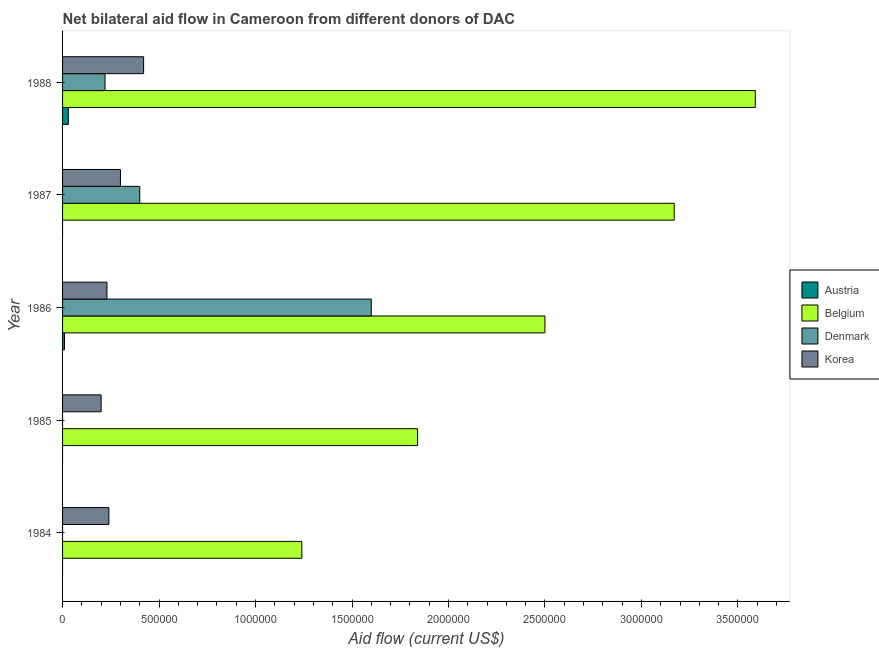How many bars are there on the 3rd tick from the top?
Ensure brevity in your answer.  4. In how many cases, is the number of bars for a given year not equal to the number of legend labels?
Keep it short and to the point. 3. What is the amount of aid given by denmark in 1985?
Your answer should be very brief. 0. Across all years, what is the maximum amount of aid given by austria?
Keep it short and to the point. 3.00e+04. Across all years, what is the minimum amount of aid given by korea?
Provide a succinct answer. 2.00e+05. In which year was the amount of aid given by austria maximum?
Keep it short and to the point. 1988. What is the total amount of aid given by denmark in the graph?
Provide a short and direct response. 2.22e+06. What is the difference between the amount of aid given by korea in 1984 and that in 1988?
Offer a very short reply. -1.80e+05. What is the difference between the amount of aid given by korea in 1984 and the amount of aid given by denmark in 1987?
Keep it short and to the point. -1.60e+05. What is the average amount of aid given by austria per year?
Ensure brevity in your answer.  8000. In the year 1986, what is the difference between the amount of aid given by denmark and amount of aid given by belgium?
Keep it short and to the point. -9.00e+05. In how many years, is the amount of aid given by denmark greater than 500000 US$?
Your answer should be very brief. 1. What is the ratio of the amount of aid given by belgium in 1984 to that in 1987?
Your answer should be compact. 0.39. Is the amount of aid given by korea in 1984 less than that in 1988?
Offer a terse response. Yes. What is the difference between the highest and the second highest amount of aid given by denmark?
Your answer should be very brief. 1.20e+06. What is the difference between the highest and the lowest amount of aid given by korea?
Your answer should be compact. 2.20e+05. How many bars are there?
Your answer should be very brief. 15. Are the values on the major ticks of X-axis written in scientific E-notation?
Provide a short and direct response. No. How many legend labels are there?
Make the answer very short. 4. What is the title of the graph?
Make the answer very short. Net bilateral aid flow in Cameroon from different donors of DAC. What is the Aid flow (current US$) of Austria in 1984?
Keep it short and to the point. 0. What is the Aid flow (current US$) in Belgium in 1984?
Make the answer very short. 1.24e+06. What is the Aid flow (current US$) of Austria in 1985?
Provide a short and direct response. 0. What is the Aid flow (current US$) in Belgium in 1985?
Your answer should be very brief. 1.84e+06. What is the Aid flow (current US$) in Denmark in 1985?
Your response must be concise. 0. What is the Aid flow (current US$) of Korea in 1985?
Your answer should be very brief. 2.00e+05. What is the Aid flow (current US$) of Austria in 1986?
Provide a succinct answer. 10000. What is the Aid flow (current US$) of Belgium in 1986?
Keep it short and to the point. 2.50e+06. What is the Aid flow (current US$) in Denmark in 1986?
Your answer should be very brief. 1.60e+06. What is the Aid flow (current US$) of Korea in 1986?
Your answer should be compact. 2.30e+05. What is the Aid flow (current US$) in Belgium in 1987?
Offer a very short reply. 3.17e+06. What is the Aid flow (current US$) in Denmark in 1987?
Your answer should be very brief. 4.00e+05. What is the Aid flow (current US$) in Korea in 1987?
Your answer should be compact. 3.00e+05. What is the Aid flow (current US$) in Austria in 1988?
Make the answer very short. 3.00e+04. What is the Aid flow (current US$) in Belgium in 1988?
Your answer should be compact. 3.59e+06. What is the Aid flow (current US$) of Denmark in 1988?
Make the answer very short. 2.20e+05. What is the Aid flow (current US$) of Korea in 1988?
Offer a very short reply. 4.20e+05. Across all years, what is the maximum Aid flow (current US$) in Austria?
Your answer should be very brief. 3.00e+04. Across all years, what is the maximum Aid flow (current US$) of Belgium?
Ensure brevity in your answer.  3.59e+06. Across all years, what is the maximum Aid flow (current US$) in Denmark?
Your answer should be very brief. 1.60e+06. Across all years, what is the minimum Aid flow (current US$) of Austria?
Your answer should be compact. 0. Across all years, what is the minimum Aid flow (current US$) in Belgium?
Keep it short and to the point. 1.24e+06. Across all years, what is the minimum Aid flow (current US$) of Denmark?
Make the answer very short. 0. Across all years, what is the minimum Aid flow (current US$) in Korea?
Offer a very short reply. 2.00e+05. What is the total Aid flow (current US$) of Belgium in the graph?
Give a very brief answer. 1.23e+07. What is the total Aid flow (current US$) in Denmark in the graph?
Your answer should be compact. 2.22e+06. What is the total Aid flow (current US$) of Korea in the graph?
Give a very brief answer. 1.39e+06. What is the difference between the Aid flow (current US$) of Belgium in 1984 and that in 1985?
Your answer should be compact. -6.00e+05. What is the difference between the Aid flow (current US$) of Belgium in 1984 and that in 1986?
Your response must be concise. -1.26e+06. What is the difference between the Aid flow (current US$) in Belgium in 1984 and that in 1987?
Provide a short and direct response. -1.93e+06. What is the difference between the Aid flow (current US$) of Korea in 1984 and that in 1987?
Provide a short and direct response. -6.00e+04. What is the difference between the Aid flow (current US$) of Belgium in 1984 and that in 1988?
Offer a very short reply. -2.35e+06. What is the difference between the Aid flow (current US$) in Korea in 1984 and that in 1988?
Offer a terse response. -1.80e+05. What is the difference between the Aid flow (current US$) in Belgium in 1985 and that in 1986?
Offer a very short reply. -6.60e+05. What is the difference between the Aid flow (current US$) in Korea in 1985 and that in 1986?
Give a very brief answer. -3.00e+04. What is the difference between the Aid flow (current US$) of Belgium in 1985 and that in 1987?
Your answer should be compact. -1.33e+06. What is the difference between the Aid flow (current US$) of Belgium in 1985 and that in 1988?
Make the answer very short. -1.75e+06. What is the difference between the Aid flow (current US$) of Belgium in 1986 and that in 1987?
Your answer should be very brief. -6.70e+05. What is the difference between the Aid flow (current US$) in Denmark in 1986 and that in 1987?
Ensure brevity in your answer.  1.20e+06. What is the difference between the Aid flow (current US$) of Belgium in 1986 and that in 1988?
Give a very brief answer. -1.09e+06. What is the difference between the Aid flow (current US$) in Denmark in 1986 and that in 1988?
Keep it short and to the point. 1.38e+06. What is the difference between the Aid flow (current US$) of Korea in 1986 and that in 1988?
Keep it short and to the point. -1.90e+05. What is the difference between the Aid flow (current US$) in Belgium in 1987 and that in 1988?
Your answer should be very brief. -4.20e+05. What is the difference between the Aid flow (current US$) in Denmark in 1987 and that in 1988?
Ensure brevity in your answer.  1.80e+05. What is the difference between the Aid flow (current US$) of Belgium in 1984 and the Aid flow (current US$) of Korea in 1985?
Your answer should be very brief. 1.04e+06. What is the difference between the Aid flow (current US$) of Belgium in 1984 and the Aid flow (current US$) of Denmark in 1986?
Provide a short and direct response. -3.60e+05. What is the difference between the Aid flow (current US$) in Belgium in 1984 and the Aid flow (current US$) in Korea in 1986?
Provide a short and direct response. 1.01e+06. What is the difference between the Aid flow (current US$) of Belgium in 1984 and the Aid flow (current US$) of Denmark in 1987?
Keep it short and to the point. 8.40e+05. What is the difference between the Aid flow (current US$) of Belgium in 1984 and the Aid flow (current US$) of Korea in 1987?
Offer a terse response. 9.40e+05. What is the difference between the Aid flow (current US$) in Belgium in 1984 and the Aid flow (current US$) in Denmark in 1988?
Keep it short and to the point. 1.02e+06. What is the difference between the Aid flow (current US$) in Belgium in 1984 and the Aid flow (current US$) in Korea in 1988?
Give a very brief answer. 8.20e+05. What is the difference between the Aid flow (current US$) in Belgium in 1985 and the Aid flow (current US$) in Korea in 1986?
Ensure brevity in your answer.  1.61e+06. What is the difference between the Aid flow (current US$) of Belgium in 1985 and the Aid flow (current US$) of Denmark in 1987?
Your answer should be very brief. 1.44e+06. What is the difference between the Aid flow (current US$) of Belgium in 1985 and the Aid flow (current US$) of Korea in 1987?
Keep it short and to the point. 1.54e+06. What is the difference between the Aid flow (current US$) of Belgium in 1985 and the Aid flow (current US$) of Denmark in 1988?
Your answer should be very brief. 1.62e+06. What is the difference between the Aid flow (current US$) of Belgium in 1985 and the Aid flow (current US$) of Korea in 1988?
Provide a short and direct response. 1.42e+06. What is the difference between the Aid flow (current US$) of Austria in 1986 and the Aid flow (current US$) of Belgium in 1987?
Give a very brief answer. -3.16e+06. What is the difference between the Aid flow (current US$) in Austria in 1986 and the Aid flow (current US$) in Denmark in 1987?
Your answer should be compact. -3.90e+05. What is the difference between the Aid flow (current US$) in Austria in 1986 and the Aid flow (current US$) in Korea in 1987?
Give a very brief answer. -2.90e+05. What is the difference between the Aid flow (current US$) of Belgium in 1986 and the Aid flow (current US$) of Denmark in 1987?
Provide a short and direct response. 2.10e+06. What is the difference between the Aid flow (current US$) in Belgium in 1986 and the Aid flow (current US$) in Korea in 1987?
Provide a short and direct response. 2.20e+06. What is the difference between the Aid flow (current US$) of Denmark in 1986 and the Aid flow (current US$) of Korea in 1987?
Your answer should be very brief. 1.30e+06. What is the difference between the Aid flow (current US$) of Austria in 1986 and the Aid flow (current US$) of Belgium in 1988?
Your response must be concise. -3.58e+06. What is the difference between the Aid flow (current US$) in Austria in 1986 and the Aid flow (current US$) in Korea in 1988?
Make the answer very short. -4.10e+05. What is the difference between the Aid flow (current US$) of Belgium in 1986 and the Aid flow (current US$) of Denmark in 1988?
Keep it short and to the point. 2.28e+06. What is the difference between the Aid flow (current US$) in Belgium in 1986 and the Aid flow (current US$) in Korea in 1988?
Ensure brevity in your answer.  2.08e+06. What is the difference between the Aid flow (current US$) of Denmark in 1986 and the Aid flow (current US$) of Korea in 1988?
Offer a very short reply. 1.18e+06. What is the difference between the Aid flow (current US$) in Belgium in 1987 and the Aid flow (current US$) in Denmark in 1988?
Provide a short and direct response. 2.95e+06. What is the difference between the Aid flow (current US$) in Belgium in 1987 and the Aid flow (current US$) in Korea in 1988?
Offer a very short reply. 2.75e+06. What is the difference between the Aid flow (current US$) in Denmark in 1987 and the Aid flow (current US$) in Korea in 1988?
Ensure brevity in your answer.  -2.00e+04. What is the average Aid flow (current US$) in Austria per year?
Ensure brevity in your answer.  8000. What is the average Aid flow (current US$) of Belgium per year?
Make the answer very short. 2.47e+06. What is the average Aid flow (current US$) in Denmark per year?
Offer a terse response. 4.44e+05. What is the average Aid flow (current US$) of Korea per year?
Your answer should be compact. 2.78e+05. In the year 1984, what is the difference between the Aid flow (current US$) in Belgium and Aid flow (current US$) in Korea?
Your answer should be very brief. 1.00e+06. In the year 1985, what is the difference between the Aid flow (current US$) of Belgium and Aid flow (current US$) of Korea?
Provide a short and direct response. 1.64e+06. In the year 1986, what is the difference between the Aid flow (current US$) in Austria and Aid flow (current US$) in Belgium?
Make the answer very short. -2.49e+06. In the year 1986, what is the difference between the Aid flow (current US$) in Austria and Aid flow (current US$) in Denmark?
Offer a terse response. -1.59e+06. In the year 1986, what is the difference between the Aid flow (current US$) of Belgium and Aid flow (current US$) of Denmark?
Ensure brevity in your answer.  9.00e+05. In the year 1986, what is the difference between the Aid flow (current US$) in Belgium and Aid flow (current US$) in Korea?
Your answer should be compact. 2.27e+06. In the year 1986, what is the difference between the Aid flow (current US$) in Denmark and Aid flow (current US$) in Korea?
Your answer should be very brief. 1.37e+06. In the year 1987, what is the difference between the Aid flow (current US$) in Belgium and Aid flow (current US$) in Denmark?
Ensure brevity in your answer.  2.77e+06. In the year 1987, what is the difference between the Aid flow (current US$) in Belgium and Aid flow (current US$) in Korea?
Keep it short and to the point. 2.87e+06. In the year 1988, what is the difference between the Aid flow (current US$) in Austria and Aid flow (current US$) in Belgium?
Provide a succinct answer. -3.56e+06. In the year 1988, what is the difference between the Aid flow (current US$) of Austria and Aid flow (current US$) of Korea?
Your answer should be compact. -3.90e+05. In the year 1988, what is the difference between the Aid flow (current US$) of Belgium and Aid flow (current US$) of Denmark?
Offer a terse response. 3.37e+06. In the year 1988, what is the difference between the Aid flow (current US$) of Belgium and Aid flow (current US$) of Korea?
Your answer should be very brief. 3.17e+06. In the year 1988, what is the difference between the Aid flow (current US$) in Denmark and Aid flow (current US$) in Korea?
Give a very brief answer. -2.00e+05. What is the ratio of the Aid flow (current US$) in Belgium in 1984 to that in 1985?
Your answer should be very brief. 0.67. What is the ratio of the Aid flow (current US$) in Korea in 1984 to that in 1985?
Provide a short and direct response. 1.2. What is the ratio of the Aid flow (current US$) of Belgium in 1984 to that in 1986?
Offer a very short reply. 0.5. What is the ratio of the Aid flow (current US$) of Korea in 1984 to that in 1986?
Provide a succinct answer. 1.04. What is the ratio of the Aid flow (current US$) of Belgium in 1984 to that in 1987?
Give a very brief answer. 0.39. What is the ratio of the Aid flow (current US$) of Korea in 1984 to that in 1987?
Your answer should be very brief. 0.8. What is the ratio of the Aid flow (current US$) of Belgium in 1984 to that in 1988?
Offer a terse response. 0.35. What is the ratio of the Aid flow (current US$) of Belgium in 1985 to that in 1986?
Your answer should be very brief. 0.74. What is the ratio of the Aid flow (current US$) in Korea in 1985 to that in 1986?
Provide a short and direct response. 0.87. What is the ratio of the Aid flow (current US$) of Belgium in 1985 to that in 1987?
Provide a short and direct response. 0.58. What is the ratio of the Aid flow (current US$) of Korea in 1985 to that in 1987?
Offer a terse response. 0.67. What is the ratio of the Aid flow (current US$) of Belgium in 1985 to that in 1988?
Provide a succinct answer. 0.51. What is the ratio of the Aid flow (current US$) of Korea in 1985 to that in 1988?
Provide a succinct answer. 0.48. What is the ratio of the Aid flow (current US$) of Belgium in 1986 to that in 1987?
Your answer should be compact. 0.79. What is the ratio of the Aid flow (current US$) of Korea in 1986 to that in 1987?
Offer a very short reply. 0.77. What is the ratio of the Aid flow (current US$) of Austria in 1986 to that in 1988?
Give a very brief answer. 0.33. What is the ratio of the Aid flow (current US$) of Belgium in 1986 to that in 1988?
Ensure brevity in your answer.  0.7. What is the ratio of the Aid flow (current US$) of Denmark in 1986 to that in 1988?
Offer a very short reply. 7.27. What is the ratio of the Aid flow (current US$) of Korea in 1986 to that in 1988?
Ensure brevity in your answer.  0.55. What is the ratio of the Aid flow (current US$) of Belgium in 1987 to that in 1988?
Your answer should be compact. 0.88. What is the ratio of the Aid flow (current US$) in Denmark in 1987 to that in 1988?
Provide a succinct answer. 1.82. What is the difference between the highest and the second highest Aid flow (current US$) of Denmark?
Ensure brevity in your answer.  1.20e+06. What is the difference between the highest and the second highest Aid flow (current US$) of Korea?
Your answer should be compact. 1.20e+05. What is the difference between the highest and the lowest Aid flow (current US$) of Belgium?
Make the answer very short. 2.35e+06. What is the difference between the highest and the lowest Aid flow (current US$) of Denmark?
Your answer should be very brief. 1.60e+06. 